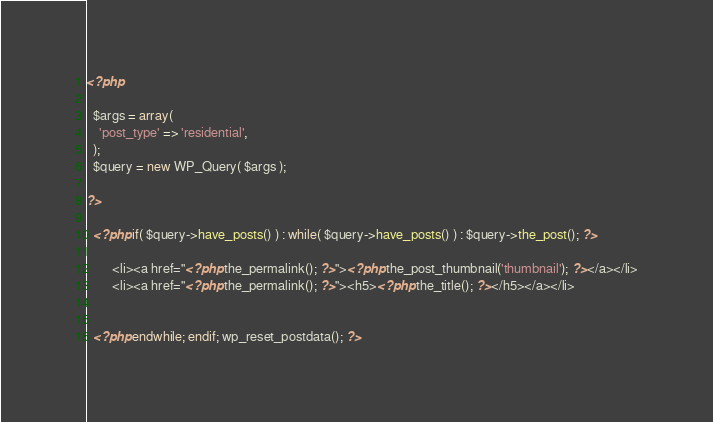Convert code to text. <code><loc_0><loc_0><loc_500><loc_500><_PHP_><?php 

  $args = array(
    'post_type' => 'residential',
  );
  $query = new WP_Query( $args );

?>

  <?php if( $query->have_posts() ) : while( $query->have_posts() ) : $query->the_post(); ?>

        <li><a href="<?php the_permalink(); ?>"><?php the_post_thumbnail('thumbnail'); ?></a></li>
        <li><a href="<?php the_permalink(); ?>"><h5><?php the_title(); ?></h5></a></li>
 

  <?php endwhile; endif; wp_reset_postdata(); ?>
</code> 